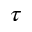<formula> <loc_0><loc_0><loc_500><loc_500>\tau</formula> 